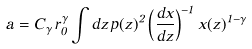<formula> <loc_0><loc_0><loc_500><loc_500>a = C _ { \gamma } \, r _ { 0 } ^ { \gamma } \int d z \, p ( z ) ^ { 2 } \left ( \frac { d x } { d z } \right ) ^ { - 1 } x ( z ) ^ { 1 - \gamma }</formula> 